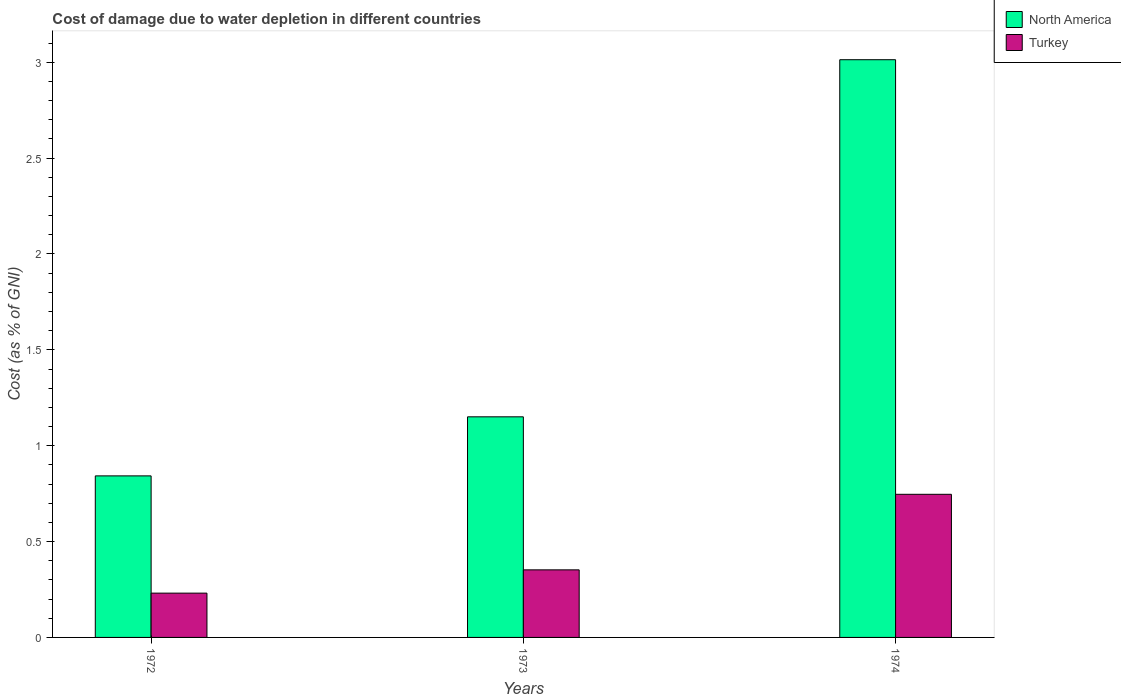How many different coloured bars are there?
Give a very brief answer. 2. How many groups of bars are there?
Your answer should be very brief. 3. Are the number of bars per tick equal to the number of legend labels?
Give a very brief answer. Yes. How many bars are there on the 1st tick from the left?
Provide a succinct answer. 2. What is the label of the 2nd group of bars from the left?
Provide a succinct answer. 1973. In how many cases, is the number of bars for a given year not equal to the number of legend labels?
Give a very brief answer. 0. What is the cost of damage caused due to water depletion in North America in 1973?
Make the answer very short. 1.15. Across all years, what is the maximum cost of damage caused due to water depletion in North America?
Offer a very short reply. 3.01. Across all years, what is the minimum cost of damage caused due to water depletion in Turkey?
Ensure brevity in your answer.  0.23. In which year was the cost of damage caused due to water depletion in Turkey maximum?
Your response must be concise. 1974. In which year was the cost of damage caused due to water depletion in Turkey minimum?
Provide a succinct answer. 1972. What is the total cost of damage caused due to water depletion in Turkey in the graph?
Offer a terse response. 1.33. What is the difference between the cost of damage caused due to water depletion in North America in 1972 and that in 1973?
Provide a succinct answer. -0.31. What is the difference between the cost of damage caused due to water depletion in Turkey in 1973 and the cost of damage caused due to water depletion in North America in 1974?
Your answer should be very brief. -2.66. What is the average cost of damage caused due to water depletion in Turkey per year?
Make the answer very short. 0.44. In the year 1974, what is the difference between the cost of damage caused due to water depletion in North America and cost of damage caused due to water depletion in Turkey?
Provide a succinct answer. 2.27. What is the ratio of the cost of damage caused due to water depletion in North America in 1972 to that in 1973?
Your response must be concise. 0.73. What is the difference between the highest and the second highest cost of damage caused due to water depletion in Turkey?
Your response must be concise. 0.39. What is the difference between the highest and the lowest cost of damage caused due to water depletion in Turkey?
Keep it short and to the point. 0.52. In how many years, is the cost of damage caused due to water depletion in Turkey greater than the average cost of damage caused due to water depletion in Turkey taken over all years?
Your answer should be compact. 1. Is the sum of the cost of damage caused due to water depletion in North America in 1972 and 1974 greater than the maximum cost of damage caused due to water depletion in Turkey across all years?
Keep it short and to the point. Yes. What does the 1st bar from the left in 1974 represents?
Keep it short and to the point. North America. What does the 2nd bar from the right in 1973 represents?
Offer a very short reply. North America. How many years are there in the graph?
Offer a terse response. 3. What is the difference between two consecutive major ticks on the Y-axis?
Offer a very short reply. 0.5. Does the graph contain grids?
Offer a terse response. No. How are the legend labels stacked?
Keep it short and to the point. Vertical. What is the title of the graph?
Provide a short and direct response. Cost of damage due to water depletion in different countries. What is the label or title of the Y-axis?
Provide a short and direct response. Cost (as % of GNI). What is the Cost (as % of GNI) in North America in 1972?
Provide a succinct answer. 0.84. What is the Cost (as % of GNI) in Turkey in 1972?
Your answer should be compact. 0.23. What is the Cost (as % of GNI) in North America in 1973?
Ensure brevity in your answer.  1.15. What is the Cost (as % of GNI) of Turkey in 1973?
Your answer should be compact. 0.35. What is the Cost (as % of GNI) in North America in 1974?
Your answer should be compact. 3.01. What is the Cost (as % of GNI) of Turkey in 1974?
Ensure brevity in your answer.  0.75. Across all years, what is the maximum Cost (as % of GNI) in North America?
Ensure brevity in your answer.  3.01. Across all years, what is the maximum Cost (as % of GNI) of Turkey?
Ensure brevity in your answer.  0.75. Across all years, what is the minimum Cost (as % of GNI) of North America?
Your response must be concise. 0.84. Across all years, what is the minimum Cost (as % of GNI) in Turkey?
Your response must be concise. 0.23. What is the total Cost (as % of GNI) in North America in the graph?
Offer a very short reply. 5.01. What is the total Cost (as % of GNI) in Turkey in the graph?
Your answer should be compact. 1.33. What is the difference between the Cost (as % of GNI) in North America in 1972 and that in 1973?
Make the answer very short. -0.31. What is the difference between the Cost (as % of GNI) of Turkey in 1972 and that in 1973?
Your answer should be compact. -0.12. What is the difference between the Cost (as % of GNI) in North America in 1972 and that in 1974?
Make the answer very short. -2.17. What is the difference between the Cost (as % of GNI) in Turkey in 1972 and that in 1974?
Offer a very short reply. -0.52. What is the difference between the Cost (as % of GNI) in North America in 1973 and that in 1974?
Offer a terse response. -1.86. What is the difference between the Cost (as % of GNI) of Turkey in 1973 and that in 1974?
Your answer should be very brief. -0.39. What is the difference between the Cost (as % of GNI) of North America in 1972 and the Cost (as % of GNI) of Turkey in 1973?
Make the answer very short. 0.49. What is the difference between the Cost (as % of GNI) in North America in 1972 and the Cost (as % of GNI) in Turkey in 1974?
Keep it short and to the point. 0.1. What is the difference between the Cost (as % of GNI) of North America in 1973 and the Cost (as % of GNI) of Turkey in 1974?
Provide a short and direct response. 0.4. What is the average Cost (as % of GNI) in North America per year?
Give a very brief answer. 1.67. What is the average Cost (as % of GNI) of Turkey per year?
Offer a terse response. 0.44. In the year 1972, what is the difference between the Cost (as % of GNI) in North America and Cost (as % of GNI) in Turkey?
Give a very brief answer. 0.61. In the year 1973, what is the difference between the Cost (as % of GNI) in North America and Cost (as % of GNI) in Turkey?
Keep it short and to the point. 0.8. In the year 1974, what is the difference between the Cost (as % of GNI) of North America and Cost (as % of GNI) of Turkey?
Offer a terse response. 2.27. What is the ratio of the Cost (as % of GNI) in North America in 1972 to that in 1973?
Offer a terse response. 0.73. What is the ratio of the Cost (as % of GNI) in Turkey in 1972 to that in 1973?
Ensure brevity in your answer.  0.66. What is the ratio of the Cost (as % of GNI) of North America in 1972 to that in 1974?
Offer a very short reply. 0.28. What is the ratio of the Cost (as % of GNI) in Turkey in 1972 to that in 1974?
Provide a succinct answer. 0.31. What is the ratio of the Cost (as % of GNI) of North America in 1973 to that in 1974?
Offer a very short reply. 0.38. What is the ratio of the Cost (as % of GNI) in Turkey in 1973 to that in 1974?
Offer a terse response. 0.47. What is the difference between the highest and the second highest Cost (as % of GNI) of North America?
Make the answer very short. 1.86. What is the difference between the highest and the second highest Cost (as % of GNI) of Turkey?
Make the answer very short. 0.39. What is the difference between the highest and the lowest Cost (as % of GNI) in North America?
Ensure brevity in your answer.  2.17. What is the difference between the highest and the lowest Cost (as % of GNI) of Turkey?
Offer a terse response. 0.52. 